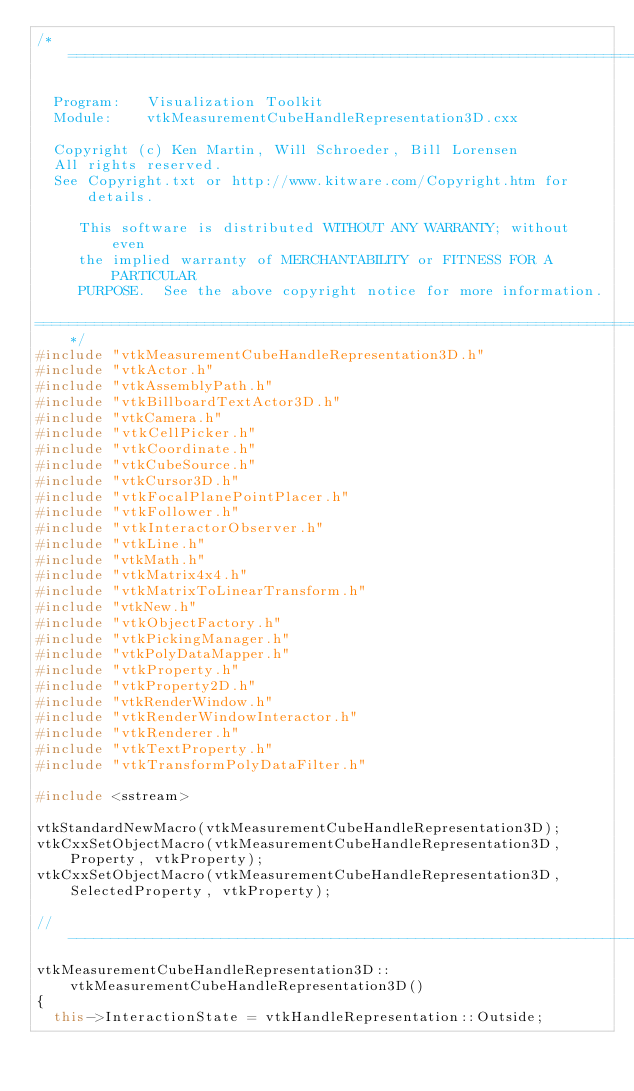<code> <loc_0><loc_0><loc_500><loc_500><_C++_>/*=========================================================================

  Program:   Visualization Toolkit
  Module:    vtkMeasurementCubeHandleRepresentation3D.cxx

  Copyright (c) Ken Martin, Will Schroeder, Bill Lorensen
  All rights reserved.
  See Copyright.txt or http://www.kitware.com/Copyright.htm for details.

     This software is distributed WITHOUT ANY WARRANTY; without even
     the implied warranty of MERCHANTABILITY or FITNESS FOR A PARTICULAR
     PURPOSE.  See the above copyright notice for more information.

=========================================================================*/
#include "vtkMeasurementCubeHandleRepresentation3D.h"
#include "vtkActor.h"
#include "vtkAssemblyPath.h"
#include "vtkBillboardTextActor3D.h"
#include "vtkCamera.h"
#include "vtkCellPicker.h"
#include "vtkCoordinate.h"
#include "vtkCubeSource.h"
#include "vtkCursor3D.h"
#include "vtkFocalPlanePointPlacer.h"
#include "vtkFollower.h"
#include "vtkInteractorObserver.h"
#include "vtkLine.h"
#include "vtkMath.h"
#include "vtkMatrix4x4.h"
#include "vtkMatrixToLinearTransform.h"
#include "vtkNew.h"
#include "vtkObjectFactory.h"
#include "vtkPickingManager.h"
#include "vtkPolyDataMapper.h"
#include "vtkProperty.h"
#include "vtkProperty2D.h"
#include "vtkRenderWindow.h"
#include "vtkRenderWindowInteractor.h"
#include "vtkRenderer.h"
#include "vtkTextProperty.h"
#include "vtkTransformPolyDataFilter.h"

#include <sstream>

vtkStandardNewMacro(vtkMeasurementCubeHandleRepresentation3D);
vtkCxxSetObjectMacro(vtkMeasurementCubeHandleRepresentation3D, Property, vtkProperty);
vtkCxxSetObjectMacro(vtkMeasurementCubeHandleRepresentation3D, SelectedProperty, vtkProperty);

//----------------------------------------------------------------------
vtkMeasurementCubeHandleRepresentation3D::vtkMeasurementCubeHandleRepresentation3D()
{
  this->InteractionState = vtkHandleRepresentation::Outside;
</code> 